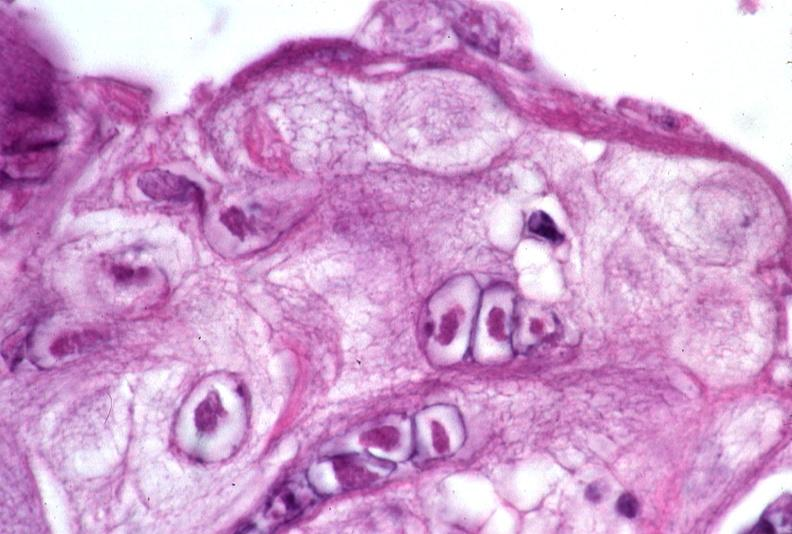does atrophy secondary to pituitectomy show skin, herpes inclusions?
Answer the question using a single word or phrase. No 